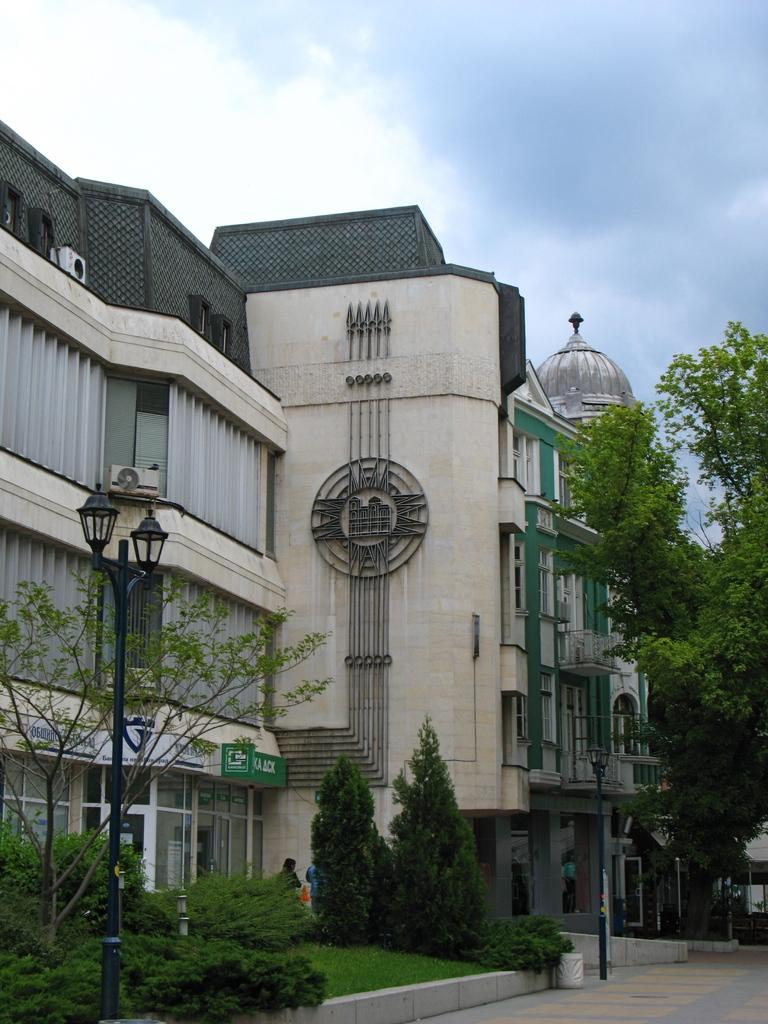What type of structures can be seen in the image? There are houses in the image. What type of vegetation is present in the image? There are plants and trees in the image. What type of street infrastructure is visible in the image? There are light poles in the image. What type of signage is present in the image? There are boards with text in the image. Who or what is present in the image? There is a person in the image. What is visible in the background of the image? The sky is visible in the image. What type of meal is the person eating in the image? There is no meal present in the image; the person is not shown eating. What type of point is being made by the person in the image? There is no indication of a point being made by the person in the image. 